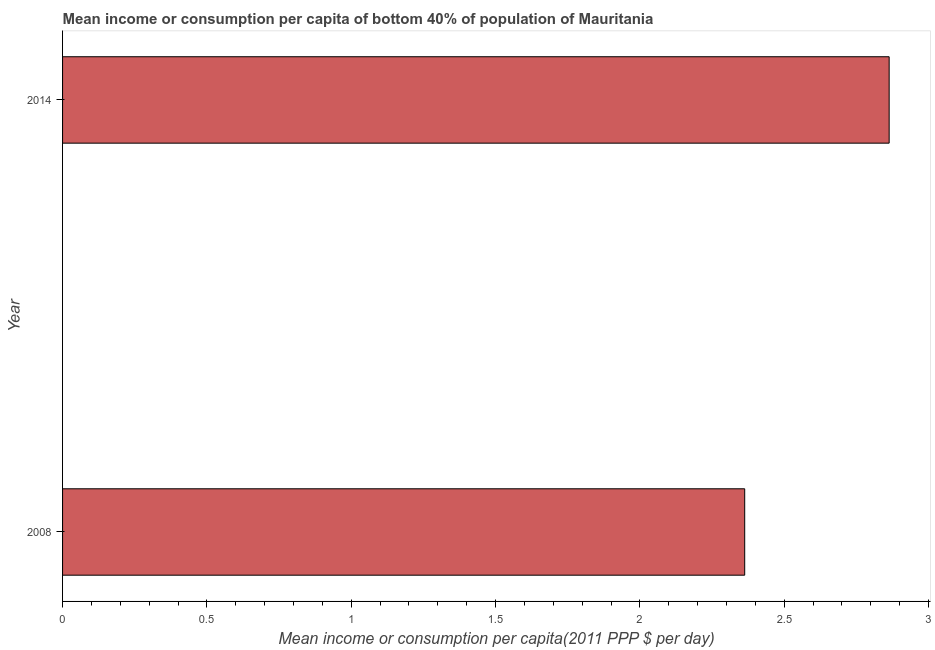What is the title of the graph?
Offer a very short reply. Mean income or consumption per capita of bottom 40% of population of Mauritania. What is the label or title of the X-axis?
Your answer should be compact. Mean income or consumption per capita(2011 PPP $ per day). What is the label or title of the Y-axis?
Make the answer very short. Year. What is the mean income or consumption in 2008?
Provide a succinct answer. 2.36. Across all years, what is the maximum mean income or consumption?
Your answer should be compact. 2.86. Across all years, what is the minimum mean income or consumption?
Your response must be concise. 2.36. What is the sum of the mean income or consumption?
Your response must be concise. 5.23. What is the average mean income or consumption per year?
Keep it short and to the point. 2.61. What is the median mean income or consumption?
Provide a succinct answer. 2.61. What is the ratio of the mean income or consumption in 2008 to that in 2014?
Provide a succinct answer. 0.82. In how many years, is the mean income or consumption greater than the average mean income or consumption taken over all years?
Your response must be concise. 1. How many years are there in the graph?
Offer a terse response. 2. What is the difference between two consecutive major ticks on the X-axis?
Make the answer very short. 0.5. Are the values on the major ticks of X-axis written in scientific E-notation?
Provide a succinct answer. No. What is the Mean income or consumption per capita(2011 PPP $ per day) in 2008?
Keep it short and to the point. 2.36. What is the Mean income or consumption per capita(2011 PPP $ per day) in 2014?
Offer a very short reply. 2.86. What is the difference between the Mean income or consumption per capita(2011 PPP $ per day) in 2008 and 2014?
Keep it short and to the point. -0.5. What is the ratio of the Mean income or consumption per capita(2011 PPP $ per day) in 2008 to that in 2014?
Offer a very short reply. 0.82. 